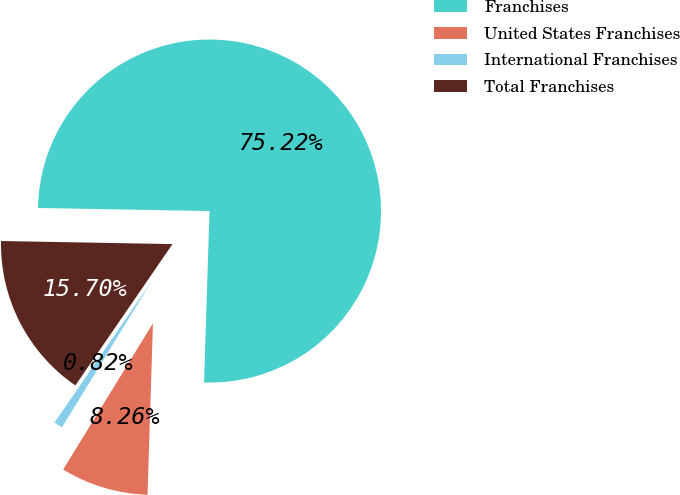<chart> <loc_0><loc_0><loc_500><loc_500><pie_chart><fcel>Franchises<fcel>United States Franchises<fcel>International Franchises<fcel>Total Franchises<nl><fcel>75.21%<fcel>8.26%<fcel>0.82%<fcel>15.7%<nl></chart> 